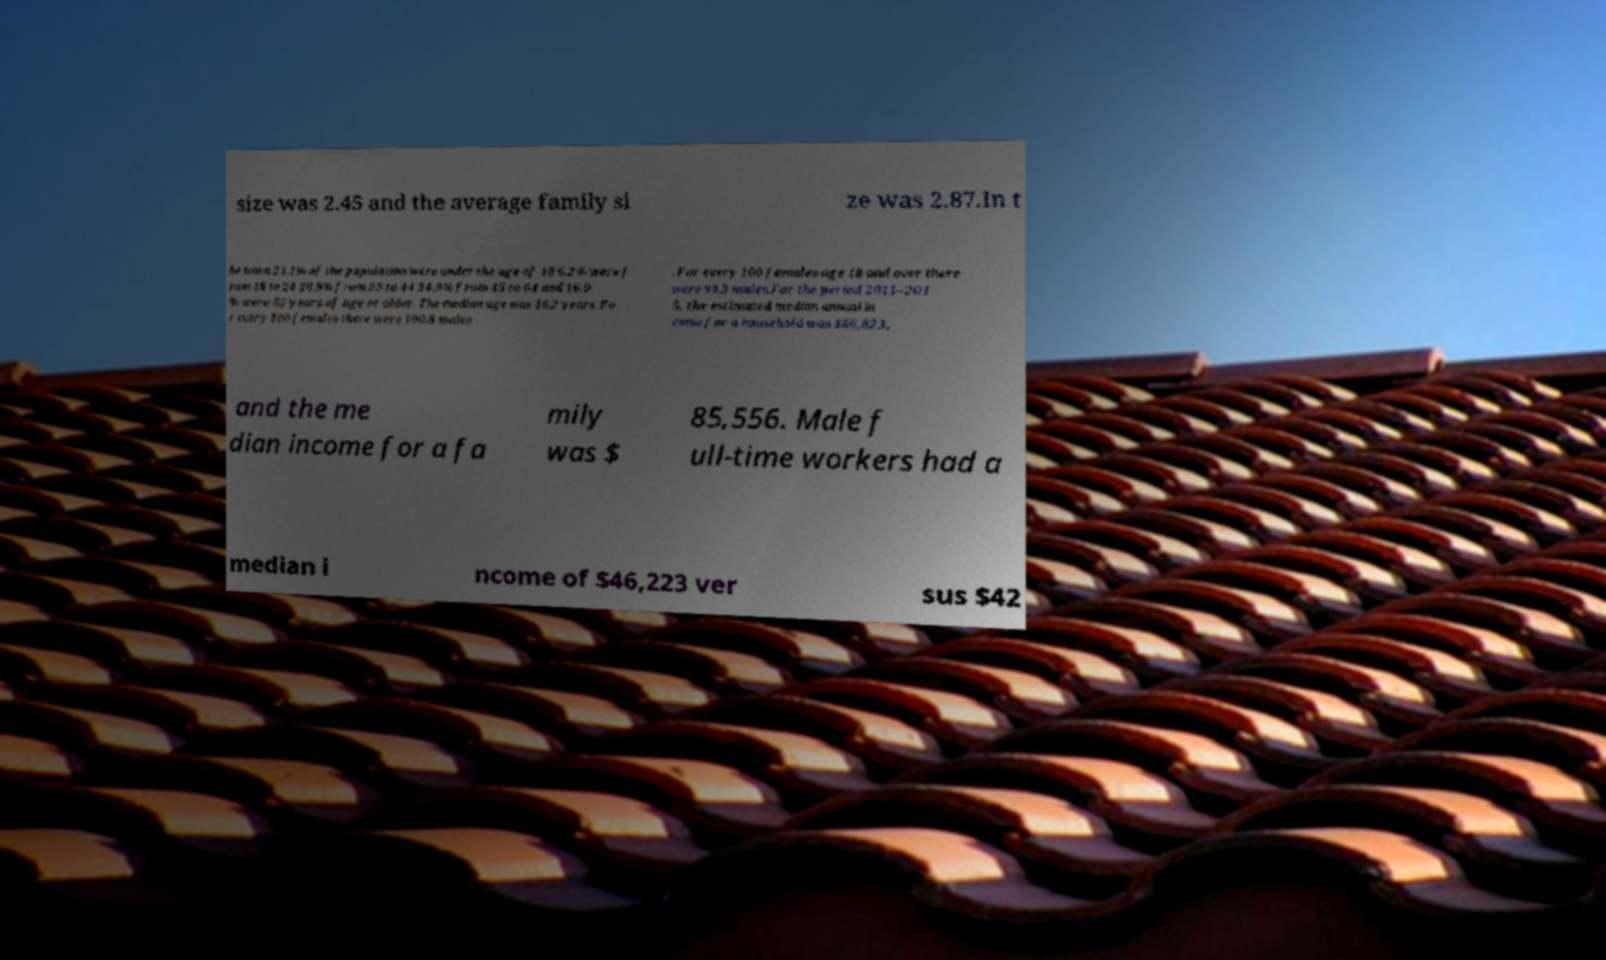Please identify and transcribe the text found in this image. size was 2.45 and the average family si ze was 2.87.In t he town 21.1% of the population were under the age of 18 6.2% were f rom 18 to 24 20.9% from 25 to 44 34.9% from 45 to 64 and 16.9 % were 65 years of age or older. The median age was 46.2 years. Fo r every 100 females there were 100.8 males . For every 100 females age 18 and over there were 99.3 males.For the period 2011–201 5, the estimated median annual in come for a household was $66,823, and the me dian income for a fa mily was $ 85,556. Male f ull-time workers had a median i ncome of $46,223 ver sus $42 